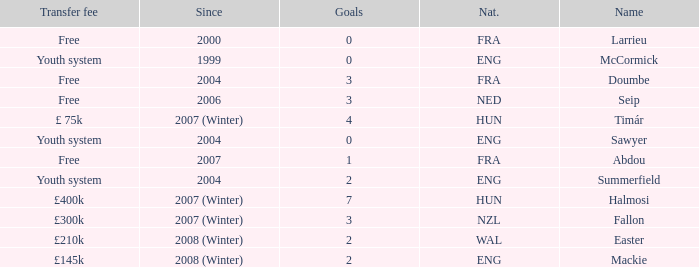What is the nationality of the player with a transfer fee of £400k? HUN. 